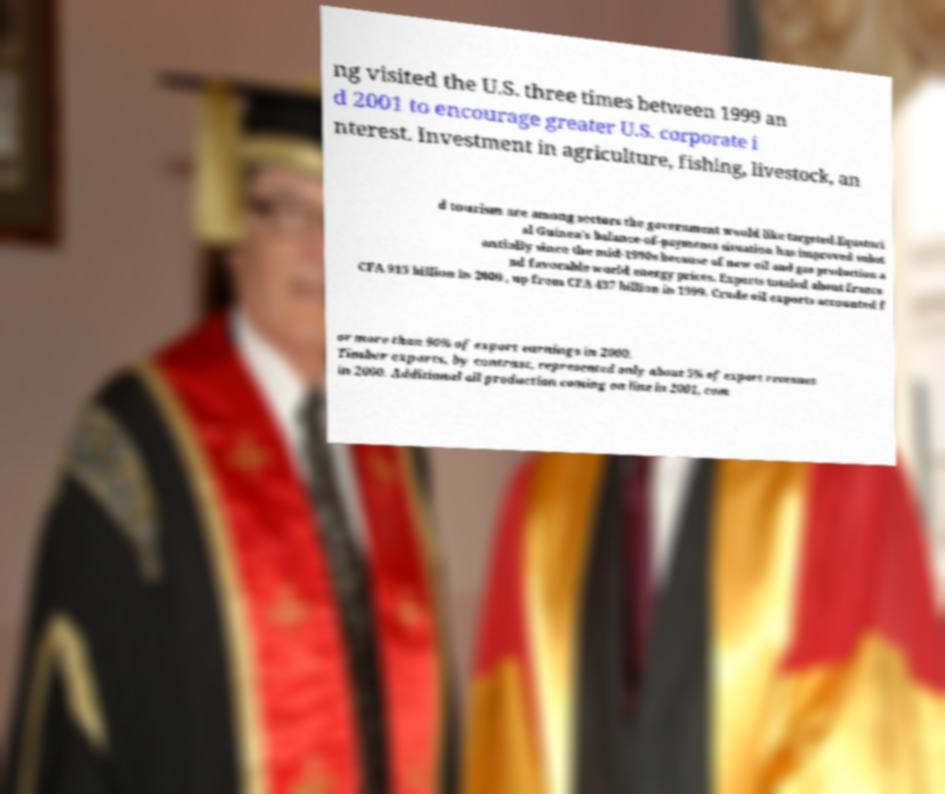What messages or text are displayed in this image? I need them in a readable, typed format. ng visited the U.S. three times between 1999 an d 2001 to encourage greater U.S. corporate i nterest. Investment in agriculture, fishing, livestock, an d tourism are among sectors the government would like targeted.Equatori al Guinea's balance-of-payments situation has improved subst antially since the mid-1990s because of new oil and gas production a nd favorable world energy prices. Exports totaled about francs CFA 915 billion in 2000 , up from CFA 437 billion in 1999. Crude oil exports accounted f or more than 90% of export earnings in 2000. Timber exports, by contrast, represented only about 5% of export revenues in 2000. Additional oil production coming on line in 2001, com 